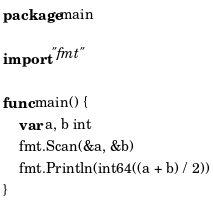<code> <loc_0><loc_0><loc_500><loc_500><_Go_>package main

import "fmt"

func main() {
	var a, b int
	fmt.Scan(&a, &b)
	fmt.Println(int64((a + b) / 2))
}
</code> 